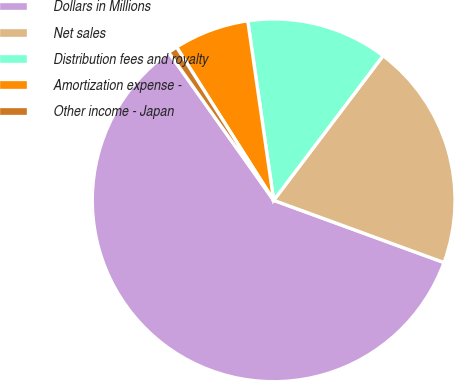<chart> <loc_0><loc_0><loc_500><loc_500><pie_chart><fcel>Dollars in Millions<fcel>Net sales<fcel>Distribution fees and royalty<fcel>Amortization expense -<fcel>Other income - Japan<nl><fcel>59.61%<fcel>20.27%<fcel>12.59%<fcel>6.71%<fcel>0.83%<nl></chart> 